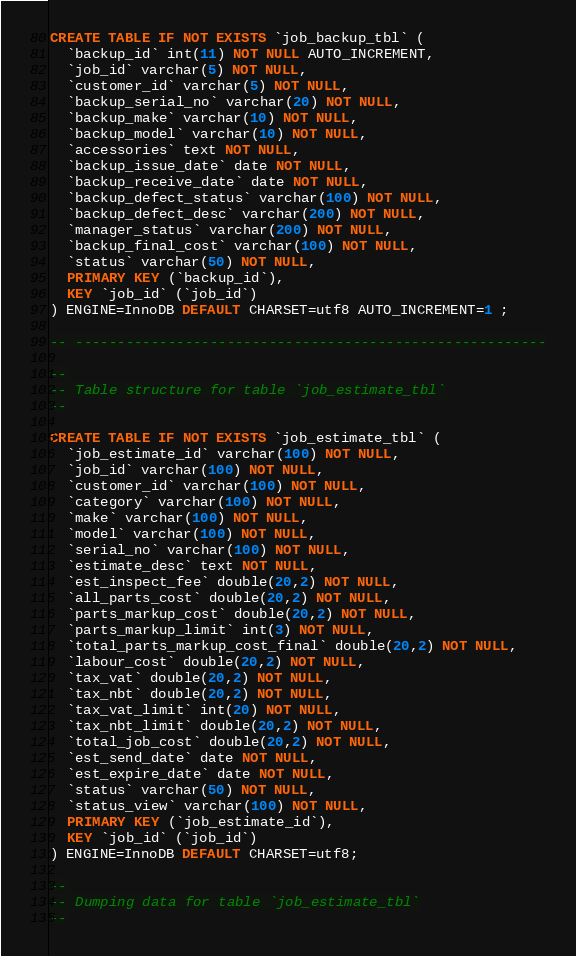Convert code to text. <code><loc_0><loc_0><loc_500><loc_500><_SQL_>CREATE TABLE IF NOT EXISTS `job_backup_tbl` (
  `backup_id` int(11) NOT NULL AUTO_INCREMENT,
  `job_id` varchar(5) NOT NULL,
  `customer_id` varchar(5) NOT NULL,
  `backup_serial_no` varchar(20) NOT NULL,
  `backup_make` varchar(10) NOT NULL,
  `backup_model` varchar(10) NOT NULL,
  `accessories` text NOT NULL,
  `backup_issue_date` date NOT NULL,
  `backup_receive_date` date NOT NULL,
  `backup_defect_status` varchar(100) NOT NULL,
  `backup_defect_desc` varchar(200) NOT NULL,
  `manager_status` varchar(200) NOT NULL,
  `backup_final_cost` varchar(100) NOT NULL,
  `status` varchar(50) NOT NULL,
  PRIMARY KEY (`backup_id`),
  KEY `job_id` (`job_id`)
) ENGINE=InnoDB DEFAULT CHARSET=utf8 AUTO_INCREMENT=1 ;

-- --------------------------------------------------------

--
-- Table structure for table `job_estimate_tbl`
--

CREATE TABLE IF NOT EXISTS `job_estimate_tbl` (
  `job_estimate_id` varchar(100) NOT NULL,
  `job_id` varchar(100) NOT NULL,
  `customer_id` varchar(100) NOT NULL,
  `category` varchar(100) NOT NULL,
  `make` varchar(100) NOT NULL,
  `model` varchar(100) NOT NULL,
  `serial_no` varchar(100) NOT NULL,
  `estimate_desc` text NOT NULL,
  `est_inspect_fee` double(20,2) NOT NULL,
  `all_parts_cost` double(20,2) NOT NULL,
  `parts_markup_cost` double(20,2) NOT NULL,
  `parts_markup_limit` int(3) NOT NULL,
  `total_parts_markup_cost_final` double(20,2) NOT NULL,
  `labour_cost` double(20,2) NOT NULL,
  `tax_vat` double(20,2) NOT NULL,
  `tax_nbt` double(20,2) NOT NULL,
  `tax_vat_limit` int(20) NOT NULL,
  `tax_nbt_limit` double(20,2) NOT NULL,
  `total_job_cost` double(20,2) NOT NULL,
  `est_send_date` date NOT NULL,
  `est_expire_date` date NOT NULL,
  `status` varchar(50) NOT NULL,
  `status_view` varchar(100) NOT NULL,
  PRIMARY KEY (`job_estimate_id`),
  KEY `job_id` (`job_id`)
) ENGINE=InnoDB DEFAULT CHARSET=utf8;

--
-- Dumping data for table `job_estimate_tbl`
--
</code> 